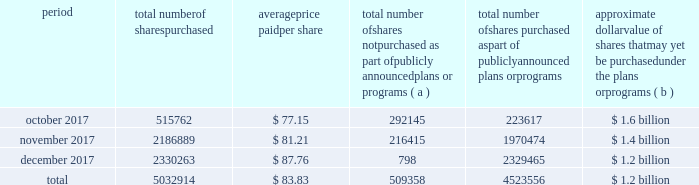Table of contents the table discloses purchases of shares of our common stock made by us or on our behalf during the fourth quarter of 2017 .
Period total number of shares purchased average price paid per share total number of shares not purchased as part of publicly announced plans or programs ( a ) total number of shares purchased as part of publicly announced plans or programs approximate dollar value of shares that may yet be purchased under the plans or programs ( b ) .
( a ) the shares reported in this column represent purchases settled in the fourth quarter of 2017 relating to ( i ) our purchases of shares in open-market transactions to meet our obligations under stock-based compensation plans , and ( ii ) our purchases of shares from our employees and non-employee directors in connection with the exercise of stock options , the vesting of restricted stock , and other stock compensation transactions in accordance with the terms of our stock-based compensation plans .
( b ) on september 21 , 2016 , we announced that our board of directors authorized our purchase of up to $ 2.5 billion of our outstanding common stock ( the 2016 program ) with no expiration date .
As of december 31 , 2017 , we had $ 1.2 billion remaining available for purchase under the 2016 program .
On january 23 , 2018 , we announced that our board of directors authorized our purchase of up to an additional $ 2.5 billion of our outstanding common stock with no expiration date. .
By what percentage did the share price increase from october to november 2017? 
Computations: ((81.21 - 77.15) / 77.15)
Answer: 0.05262. 